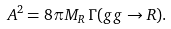Convert formula to latex. <formula><loc_0><loc_0><loc_500><loc_500>A ^ { 2 } = 8 \pi M _ { R } \, \Gamma ( g g \rightarrow R ) .</formula> 